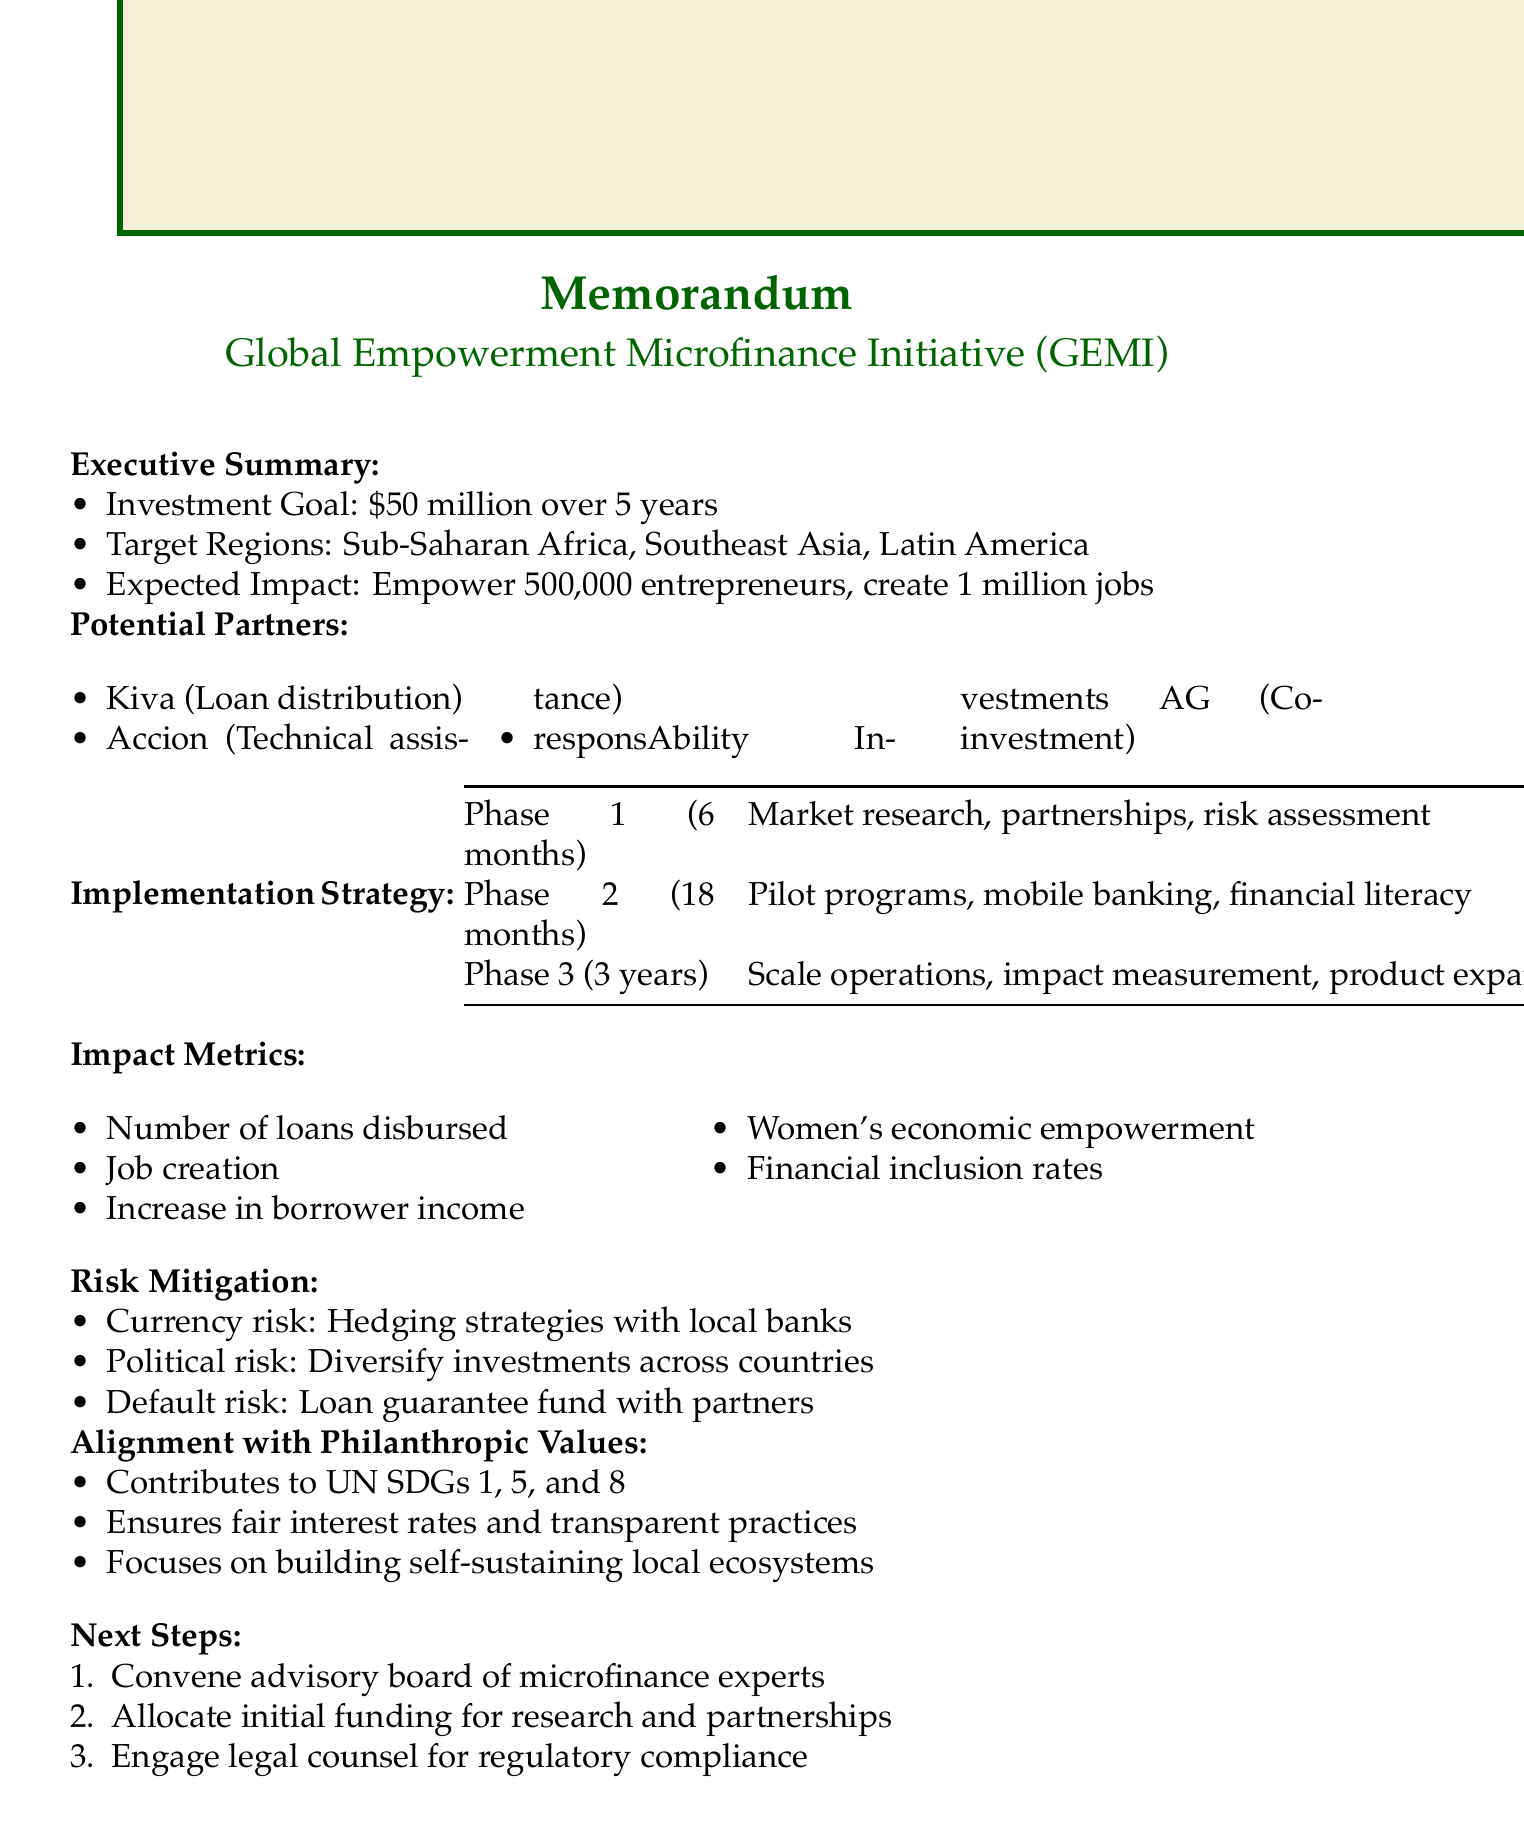What is the investment goal? The investment goal is outlined in the executive summary of the document.
Answer: $50 million over 5 years Which regions are targeted by the initiative? The target regions are specified in the executive summary of the document.
Answer: Sub-Saharan Africa, Southeast Asia, Latin America Who is responsible for loan distribution? The potential partners section identifies Kiva's role in the initiative.
Answer: Kiva What is the duration of Phase 2? The implementation strategy details the duration for each phase.
Answer: 18 months What impact metric relates to women's financial independence? The impact metrics section describes various outcomes expected from the initiative.
Answer: Women's economic empowerment Which organization focuses on technical assistance? The potential partners section outlines the expertise and roles of different organizations.
Answer: Accion What steps are listed as next moves? The next steps section outlines specific actions to be taken after the document's conclusions.
Answer: Convene advisory board of microfinance experts How many jobs does the initiative expect to create? The expected impact of the initiative is described in the executive summary.
Answer: 1 million jobs What risk is mitigated by diversifying investments? The risk mitigation section addresses several risks associated with the initiative.
Answer: Political risk 